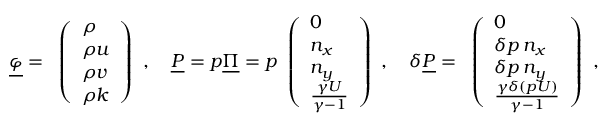<formula> <loc_0><loc_0><loc_500><loc_500>\underline { \varphi } = \begin{array} { l } { \left ( \begin{array} { l } { \rho } \\ { \rho u } \\ { \rho v } \\ { \rho k } \end{array} \right ) } \end{array} , \quad \underline { P } = p \underline { \Pi } = p \begin{array} { l } { \left ( \begin{array} { l } { 0 } \\ { n _ { x } } \\ { n _ { y } } \\ { \frac { \gamma U } { \gamma - 1 } } \end{array} \right ) } \end{array} , \quad \delta \underline { P } = \begin{array} { l } { \left ( \begin{array} { l } { 0 } \\ { \delta p \, n _ { x } } \\ { \delta p \, n _ { y } } \\ { \frac { \gamma \delta ( p U ) } { \gamma - 1 } } \end{array} \right ) } \end{array} ,</formula> 